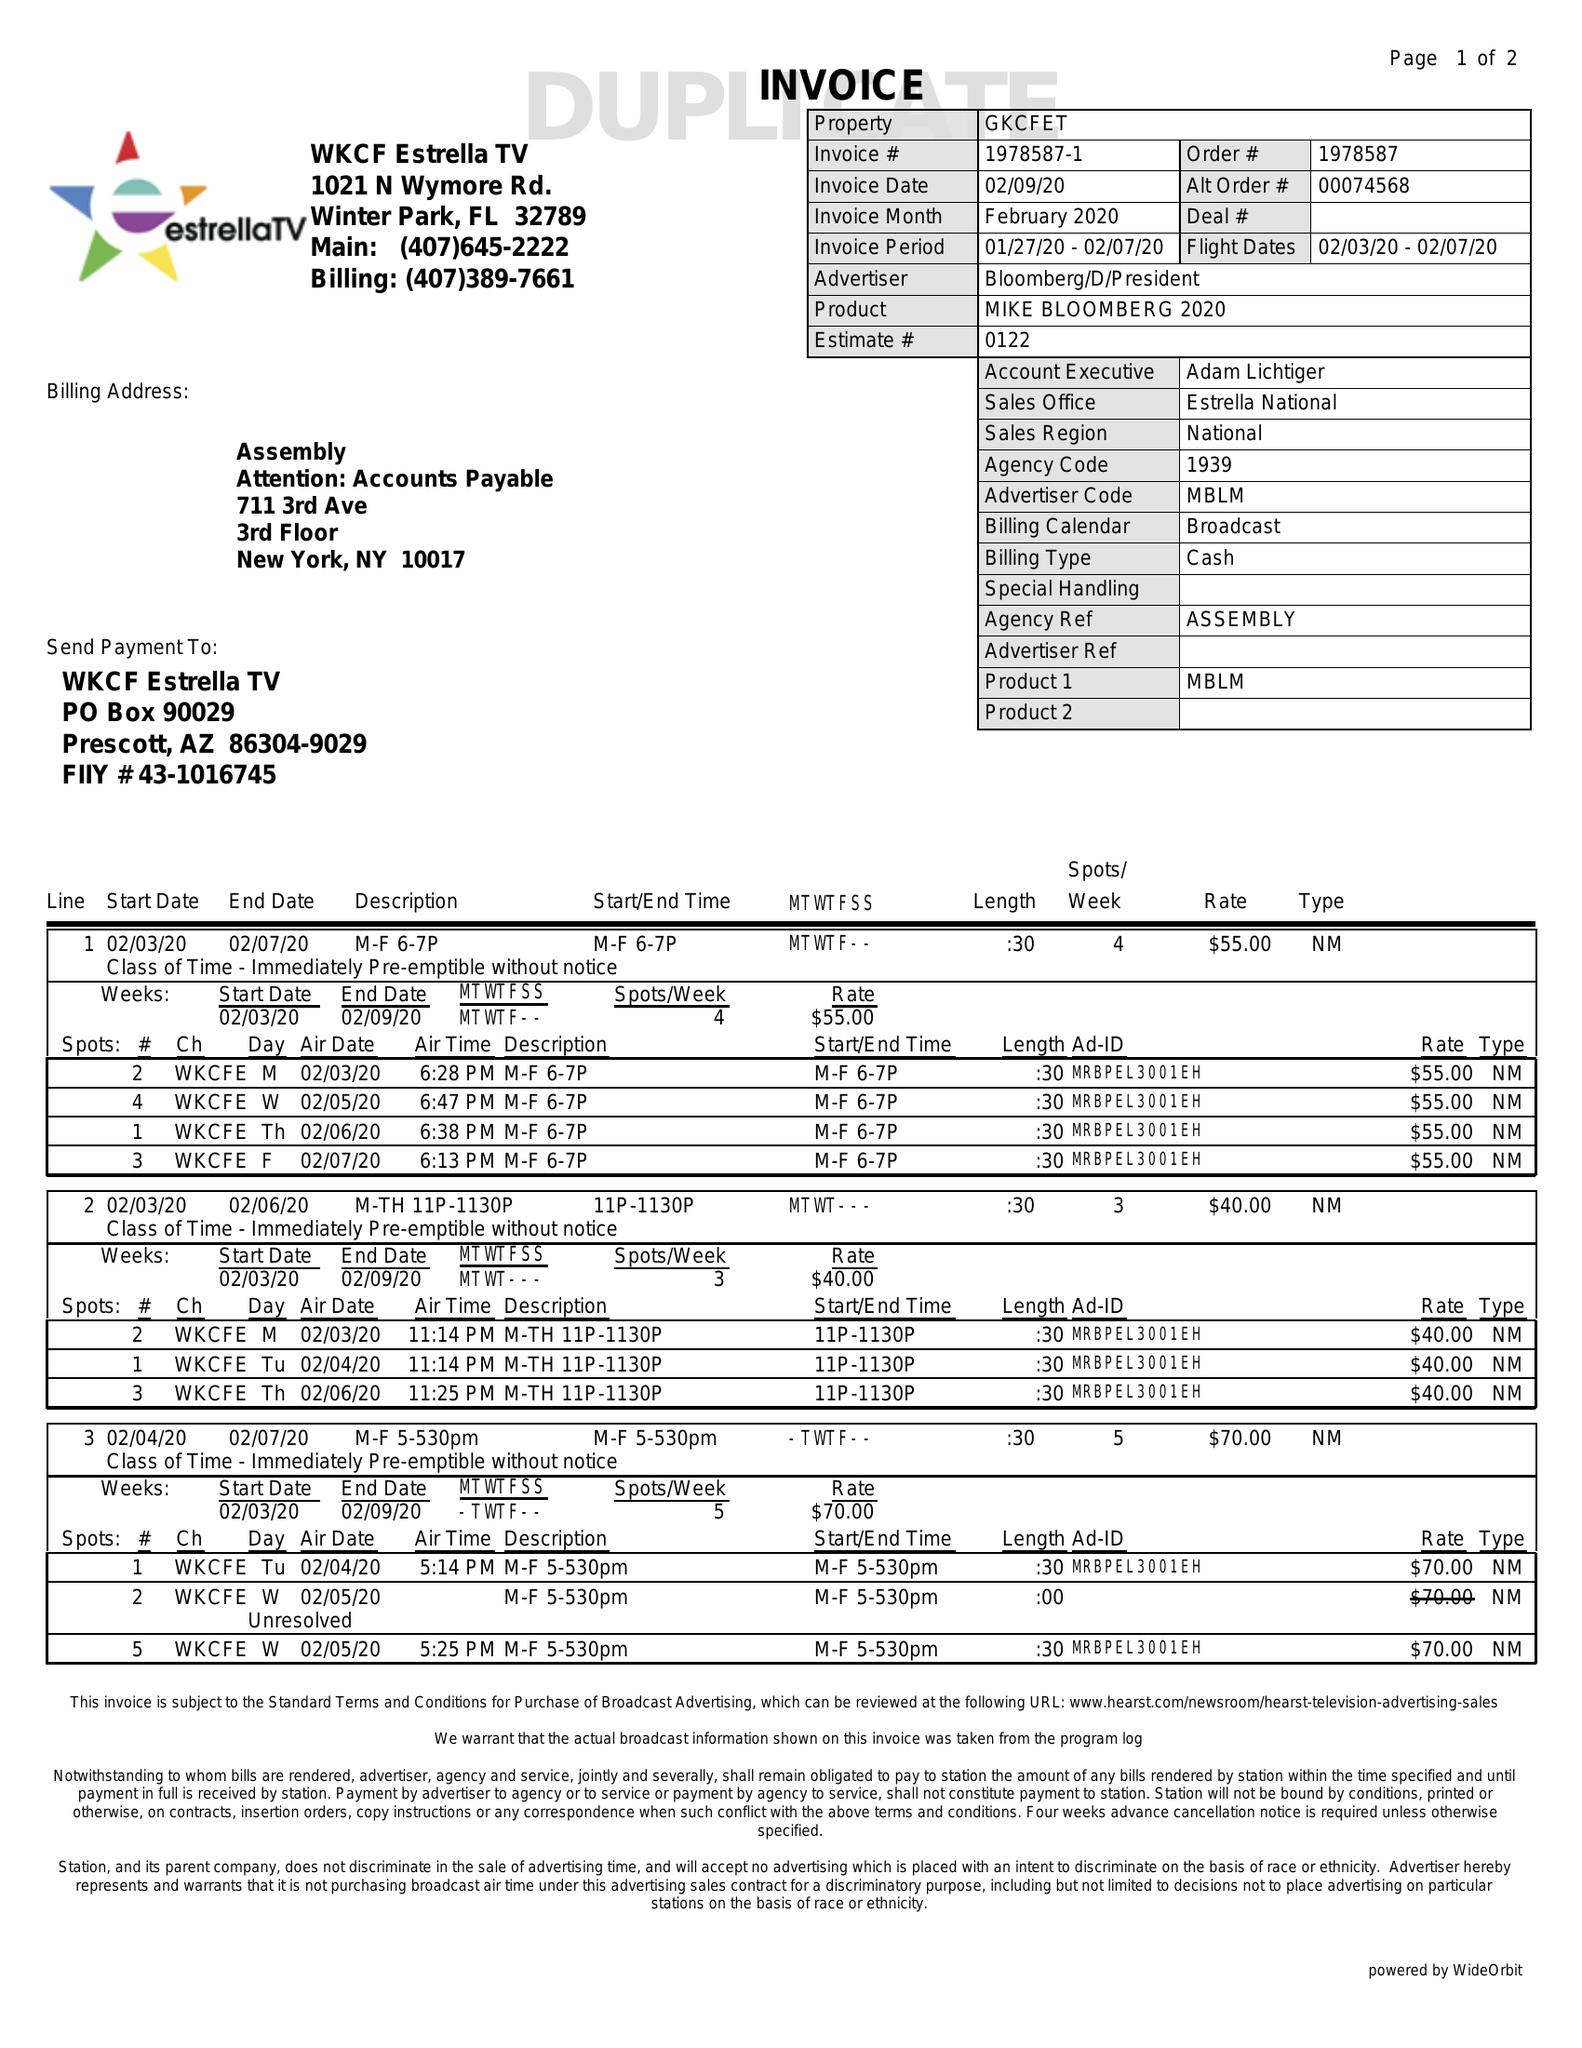What is the value for the advertiser?
Answer the question using a single word or phrase. BLOOMBERG/D/PRESIDENT 